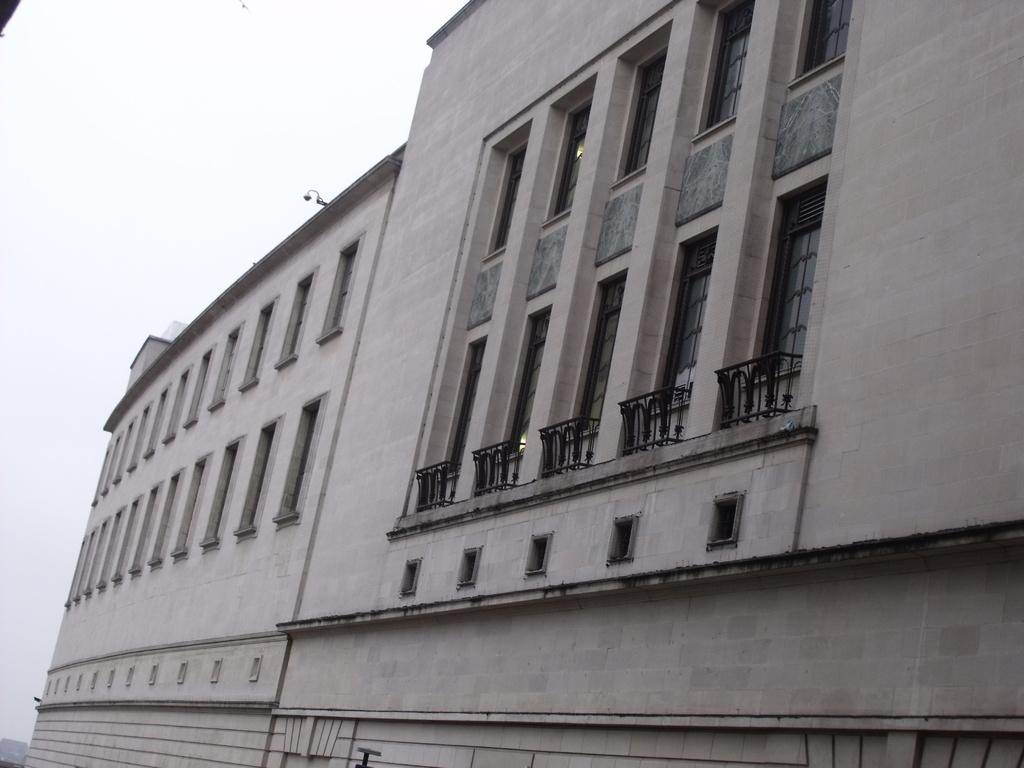What type of structure is present in the image? There is a building in the image. What can be seen in the background of the image? The sky is visible in the background of the image. What type of treatment is being administered to the building in the image? There is no treatment being administered to the building in the image; it is a static structure. 